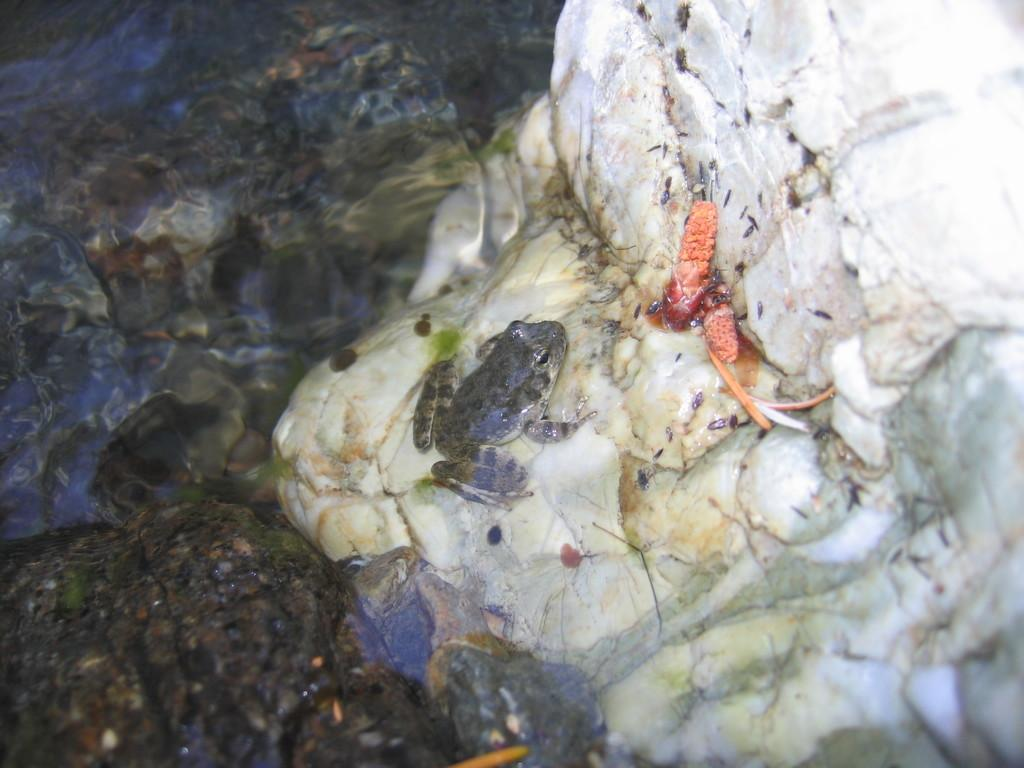What animal is present in the image? There is a frog in the image. What colors can be seen on the frog? The frog is in white and grey color. Where is the frog located? The frog is on a rock. Can you describe the rock to the left of the frog? The rock to the left is black in color, but it is blurry. What type of cup is being used by the frog in the image? There is no cup present in the image; it features a frog on a rock. Can you describe the hill in the background of the image? There is no hill visible in the image; it only shows a frog on a rock and a blurry black rock to the left. 